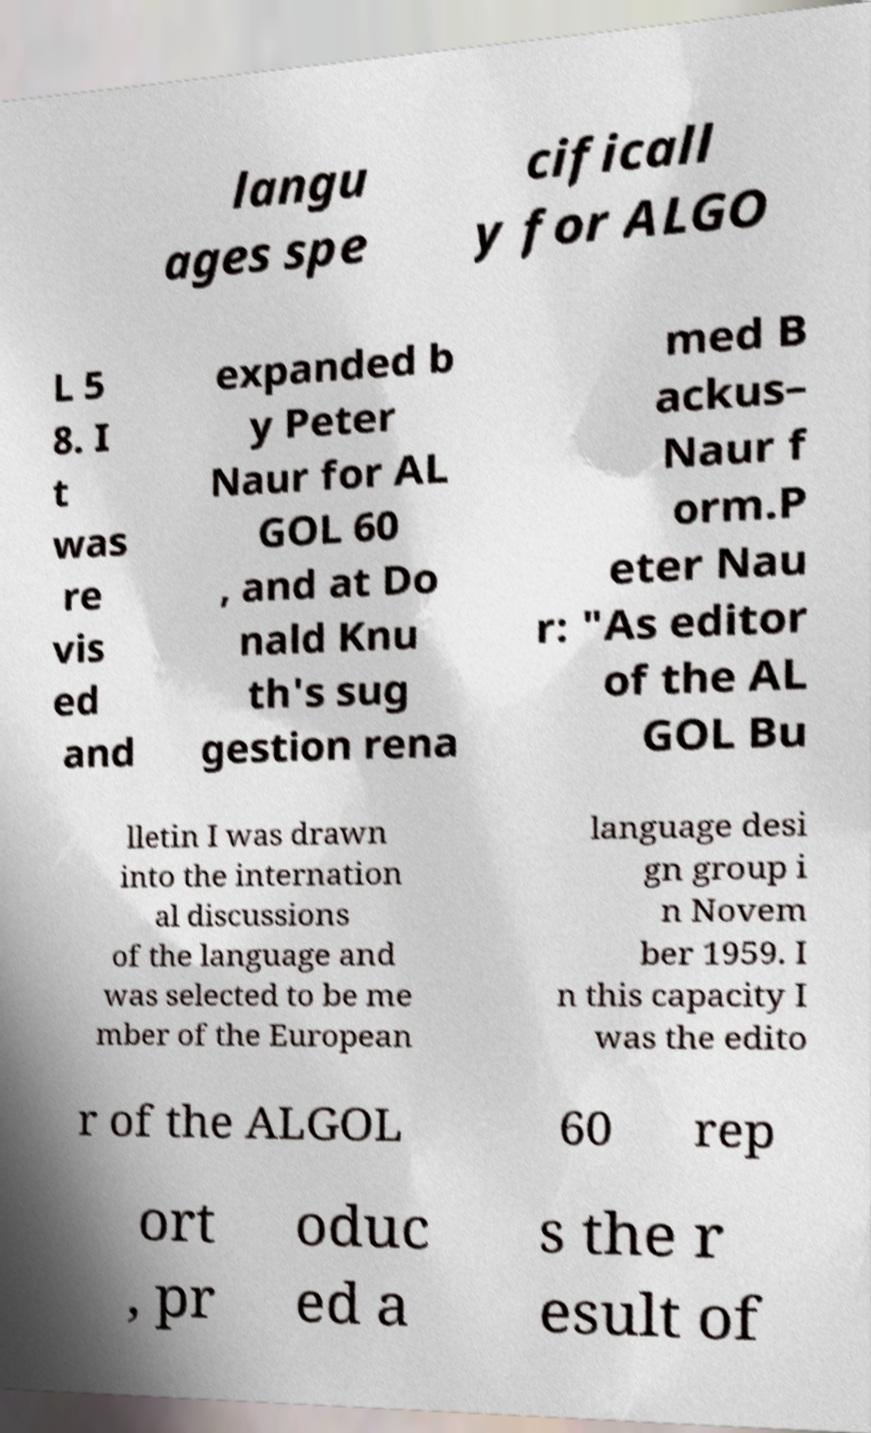There's text embedded in this image that I need extracted. Can you transcribe it verbatim? langu ages spe cificall y for ALGO L 5 8. I t was re vis ed and expanded b y Peter Naur for AL GOL 60 , and at Do nald Knu th's sug gestion rena med B ackus– Naur f orm.P eter Nau r: "As editor of the AL GOL Bu lletin I was drawn into the internation al discussions of the language and was selected to be me mber of the European language desi gn group i n Novem ber 1959. I n this capacity I was the edito r of the ALGOL 60 rep ort , pr oduc ed a s the r esult of 